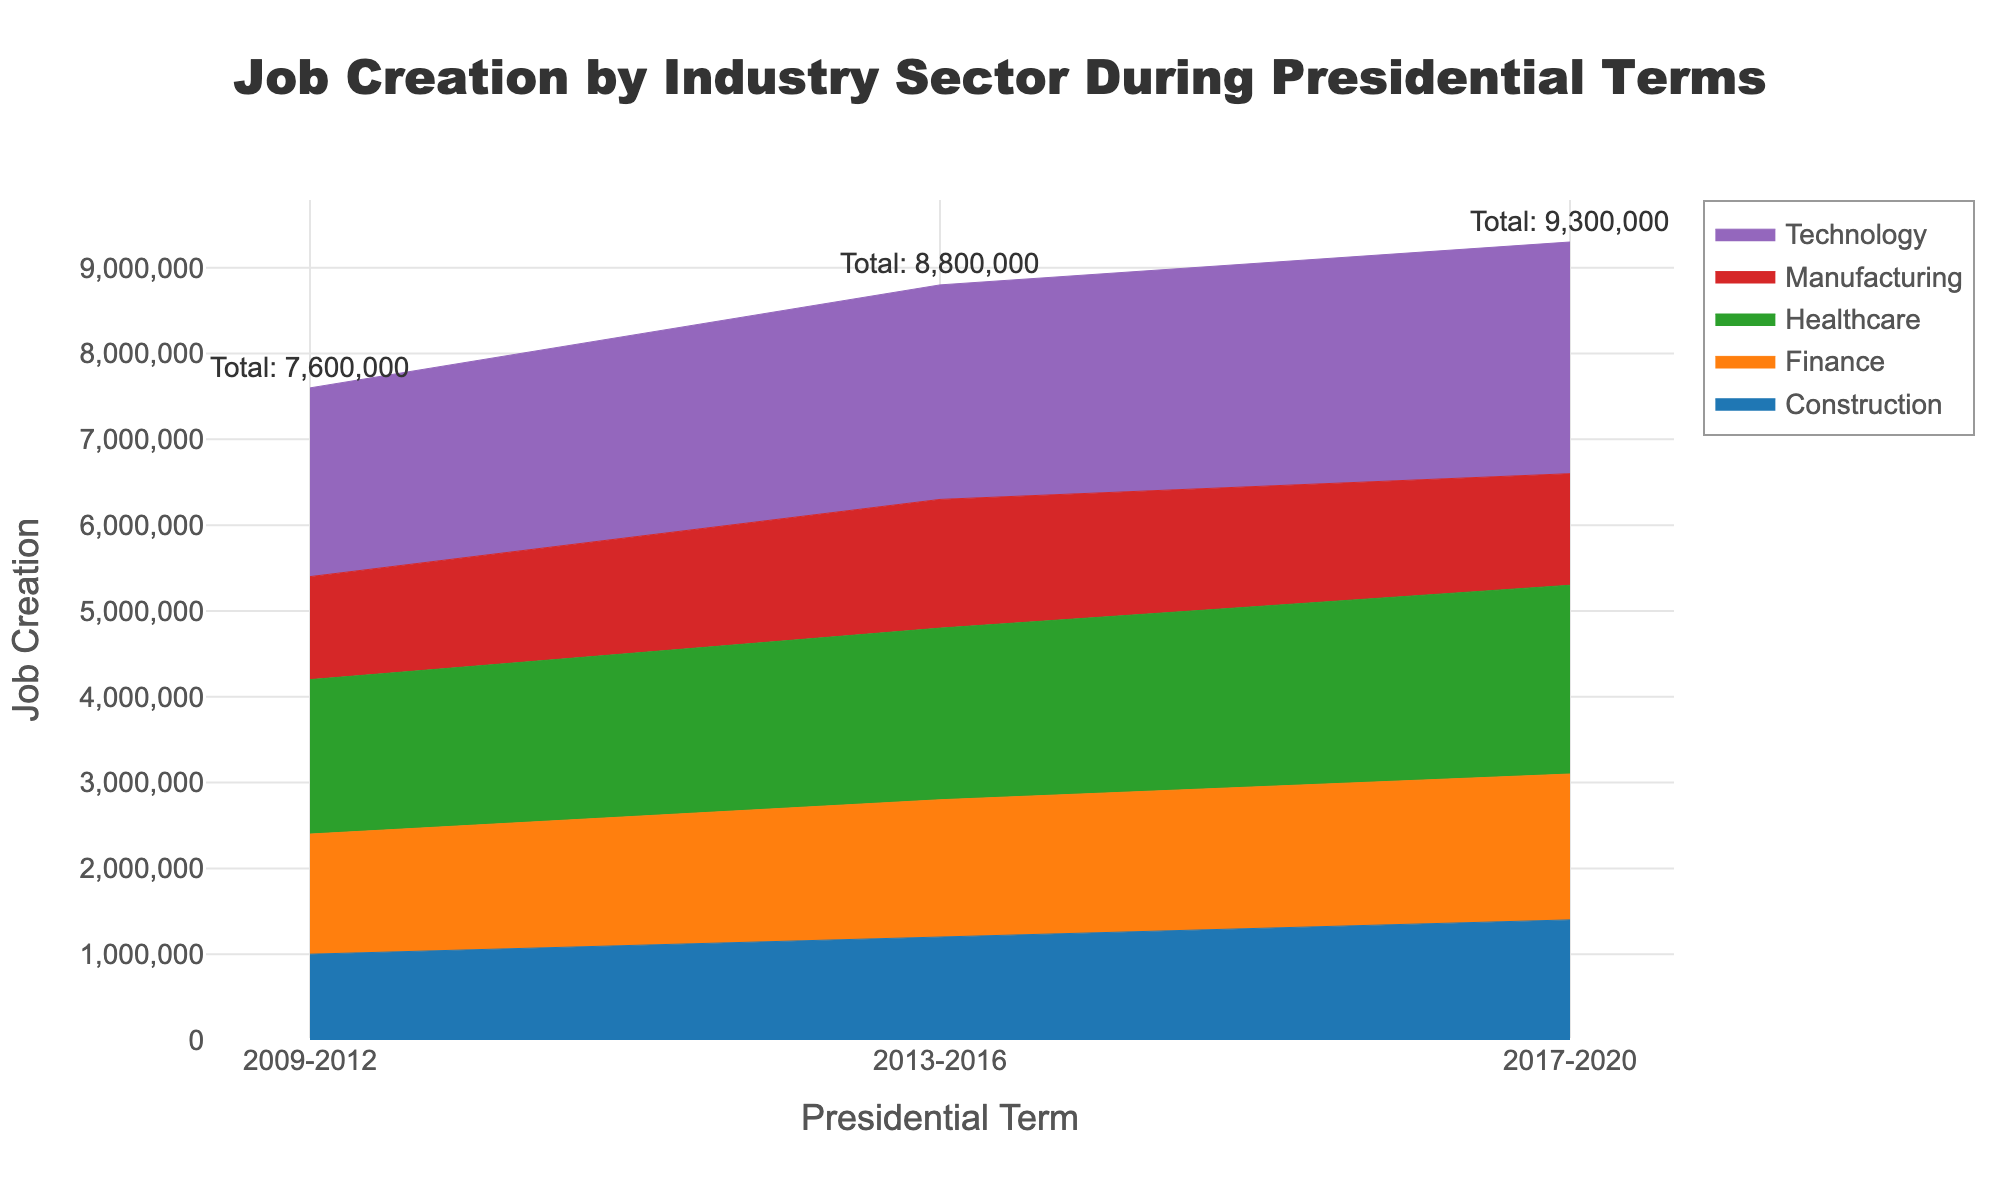what is the title of the chart? The title of the chart is located at the top center of the figure. To find it, just look for the text at the top. It reads "Job Creation by Industry Sector During Presidential Terms."
Answer: Job Creation by Industry Sector During Presidential Terms Which industry sector has the highest job creation in 2017-2020? To determine the highest job creation in 2017-2020, look at the heights of the step areas in that period and find the tallest one. The Technology sector has the highest job creation in 2017-2020.
Answer: Technology How does job creation in Manufacturing change across the presidential terms? To identify the changes in manufacturing job creation, follow the line associated with the Manufacturing sector across the different presidential terms (2009-2012, 2013-2016, 2017-2020). You will see that it increases from 1,200,000 during 2009-2012 to 1,500,000 during 2013-2016 and then decreases to 1,300,000 during 2017-2020.
Answer: Increases then decreases What is the total job creation in 2013-2016? To find the total job creation in 2013-2016, sum up the job creation numbers from all sectors during that period. (1,500,000 + 2,500,000 + 2,000,000 + 1,600,000 + 1,200,000) = 8,800,000.
Answer: 8,800,000 Which sectors show an increase in job creation from 2009-2012 to 2013-2016? Compare the job creation numbers for each sector between the two presidential terms (2009-2012 and 2013-2016). The sectors that show an increase are Manufacturing, Technology, Healthcare, Finance, and Construction.
Answer: All sectors What is the difference in job creation between Technology and Manufacturing in 2017-2020? To find the difference, subtract the job creation numbers for Manufacturing from Technology in 2017-2020. (2,700,000 - 1,300,000) = 1,400,000.
Answer: 1,400,000 What percentage of total job creation in 2009-2012 was contributed by the Healthcare sector? Calculate the total job creation in 2009-2012 and then determine the percentage contributed by the Healthcare sector. Total job creation = 1,200,000 + 2,200,000 + 1,800,000 + 1,400,000 + 1,000,000 = 7,600,000. Percentage = (1,800,000 / 7,600,000) * 100 ≈ 23.68%.
Answer: 23.68% Which sector has shown consistent growth in job creation across all presidential terms? To identify the consistently growing sector, look at the trends for each sector across all three presidential terms. The Technology sector shows consistent growth from 2009-2012 to 2013-2016 and then again from 2013-2016 to 2017-2020.
Answer: Technology What is the relative contribution of the Finance sector to total job creation in 2017-2020 compared to 2013-2016? Calculate the total job creation for each term, then find the percentage contribution of the Finance sector. For 2017-2020: (1,700,000 / (1,300,000 + 2,700,000 + 2,200,000 + 1,700,000 + 1,400,000)) * 100 ≈ 15.60%. For 2013-2016: (1,600,000 / 8,800,000) * 100 ≈ 18.18%. Relative contribution = 15.60% / 18.18% ≈ 0.858 or 85.8%.
Answer: 85.8% 